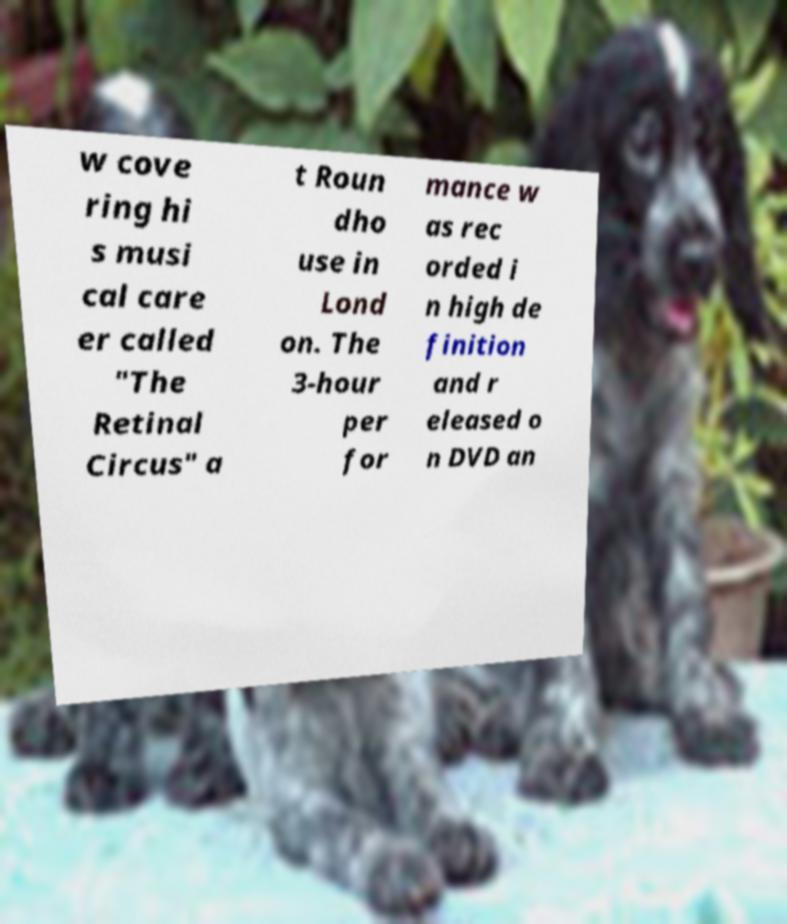There's text embedded in this image that I need extracted. Can you transcribe it verbatim? w cove ring hi s musi cal care er called "The Retinal Circus" a t Roun dho use in Lond on. The 3-hour per for mance w as rec orded i n high de finition and r eleased o n DVD an 